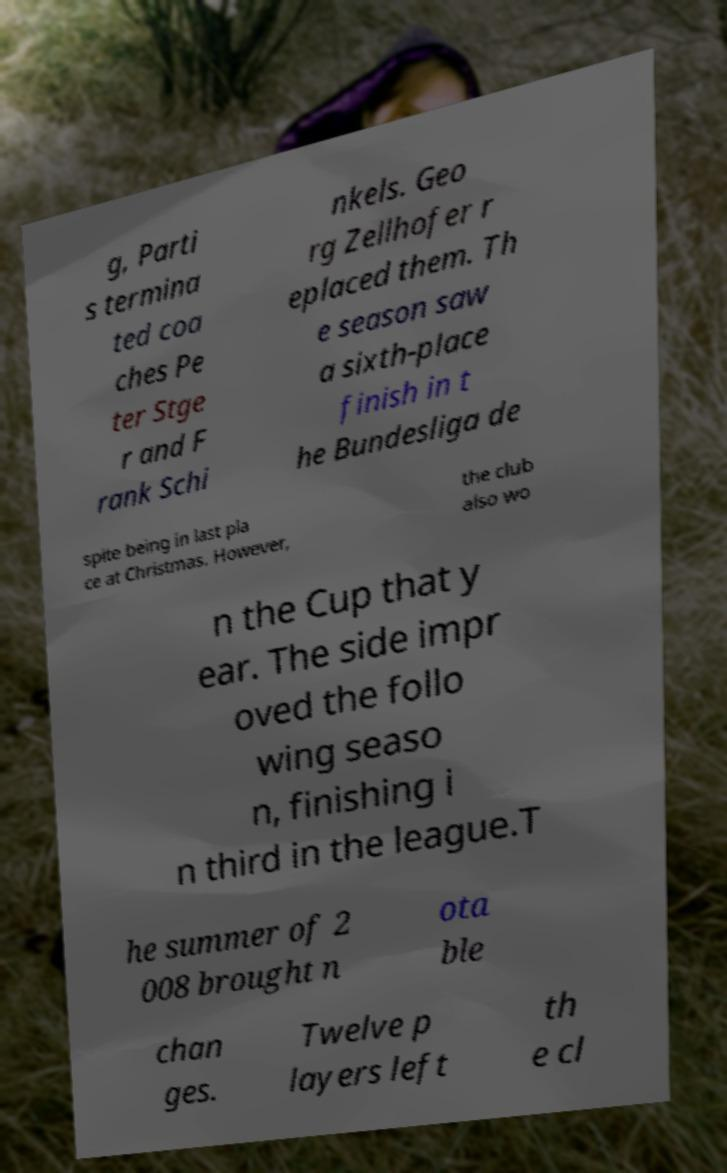Please read and relay the text visible in this image. What does it say? g, Parti s termina ted coa ches Pe ter Stge r and F rank Schi nkels. Geo rg Zellhofer r eplaced them. Th e season saw a sixth-place finish in t he Bundesliga de spite being in last pla ce at Christmas. However, the club also wo n the Cup that y ear. The side impr oved the follo wing seaso n, finishing i n third in the league.T he summer of 2 008 brought n ota ble chan ges. Twelve p layers left th e cl 